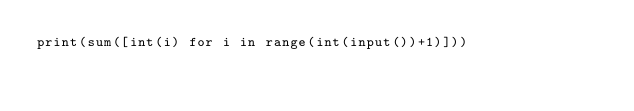<code> <loc_0><loc_0><loc_500><loc_500><_Python_>print(sum([int(i) for i in range(int(input())+1)]))</code> 